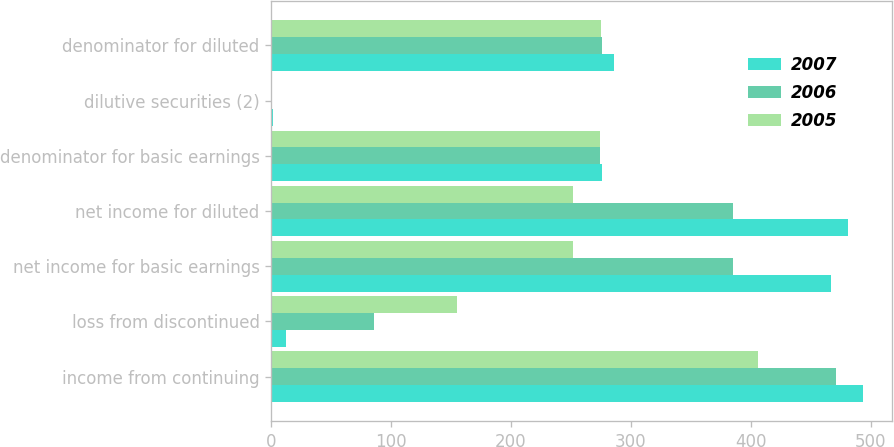Convert chart to OTSL. <chart><loc_0><loc_0><loc_500><loc_500><stacked_bar_chart><ecel><fcel>income from continuing<fcel>loss from discontinued<fcel>net income for basic earnings<fcel>net income for diluted<fcel>denominator for basic earnings<fcel>dilutive securities (2)<fcel>denominator for diluted<nl><fcel>2007<fcel>493.4<fcel>12.1<fcel>467.1<fcel>481.3<fcel>276<fcel>1.8<fcel>286.1<nl><fcel>2006<fcel>470.7<fcel>85.7<fcel>385<fcel>385<fcel>274.6<fcel>0.9<fcel>275.5<nl><fcel>2005<fcel>406.3<fcel>155<fcel>251.3<fcel>251.3<fcel>274.4<fcel>0.5<fcel>274.9<nl></chart> 